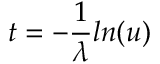<formula> <loc_0><loc_0><loc_500><loc_500>t = - { \frac { 1 } { \lambda } } \ln ( u )</formula> 